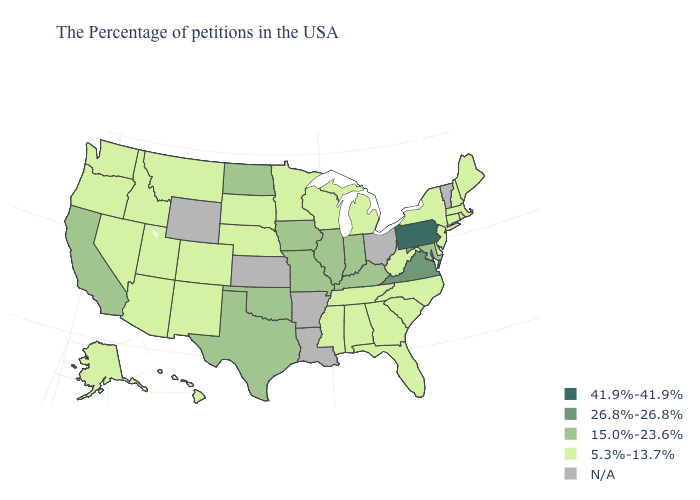Does Illinois have the highest value in the MidWest?
Concise answer only. Yes. What is the value of Colorado?
Be succinct. 5.3%-13.7%. What is the lowest value in states that border Florida?
Be succinct. 5.3%-13.7%. What is the value of Missouri?
Answer briefly. 15.0%-23.6%. Among the states that border Washington , which have the highest value?
Concise answer only. Idaho, Oregon. What is the value of Oregon?
Write a very short answer. 5.3%-13.7%. Which states have the lowest value in the USA?
Short answer required. Maine, Massachusetts, Rhode Island, New Hampshire, Connecticut, New York, New Jersey, Delaware, North Carolina, South Carolina, West Virginia, Florida, Georgia, Michigan, Alabama, Tennessee, Wisconsin, Mississippi, Minnesota, Nebraska, South Dakota, Colorado, New Mexico, Utah, Montana, Arizona, Idaho, Nevada, Washington, Oregon, Alaska, Hawaii. What is the value of Montana?
Quick response, please. 5.3%-13.7%. Among the states that border North Carolina , does Virginia have the highest value?
Write a very short answer. Yes. Does Pennsylvania have the highest value in the USA?
Be succinct. Yes. Name the states that have a value in the range 26.8%-26.8%?
Write a very short answer. Virginia. Name the states that have a value in the range N/A?
Quick response, please. Vermont, Ohio, Louisiana, Arkansas, Kansas, Wyoming. Which states have the lowest value in the USA?
Be succinct. Maine, Massachusetts, Rhode Island, New Hampshire, Connecticut, New York, New Jersey, Delaware, North Carolina, South Carolina, West Virginia, Florida, Georgia, Michigan, Alabama, Tennessee, Wisconsin, Mississippi, Minnesota, Nebraska, South Dakota, Colorado, New Mexico, Utah, Montana, Arizona, Idaho, Nevada, Washington, Oregon, Alaska, Hawaii. What is the value of Florida?
Quick response, please. 5.3%-13.7%. Does the map have missing data?
Concise answer only. Yes. 